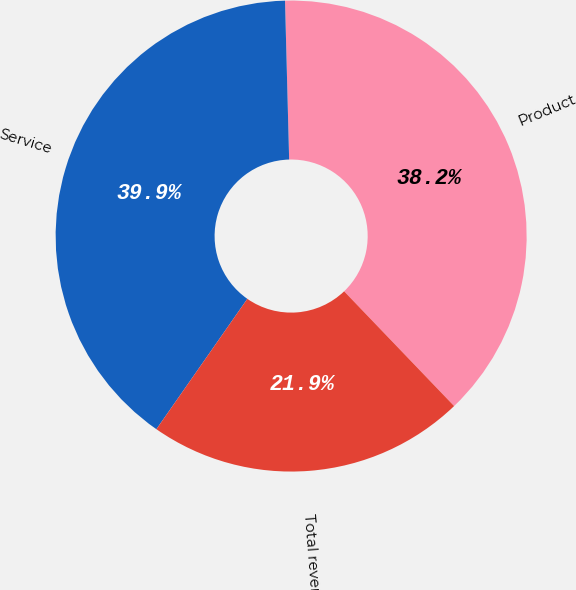Convert chart to OTSL. <chart><loc_0><loc_0><loc_500><loc_500><pie_chart><fcel>Product<fcel>Service<fcel>Total revenues<nl><fcel>38.25%<fcel>39.89%<fcel>21.86%<nl></chart> 